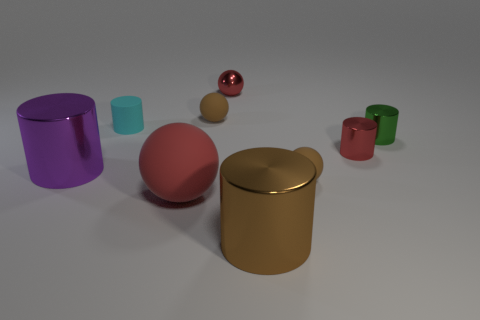How would you describe the lighting in this scene? The lighting appears soft and diffuse, with a subtle gradient on the background, suggesting an artificial studio light setup that evenly illuminates the scene without creating harsh shadows. 